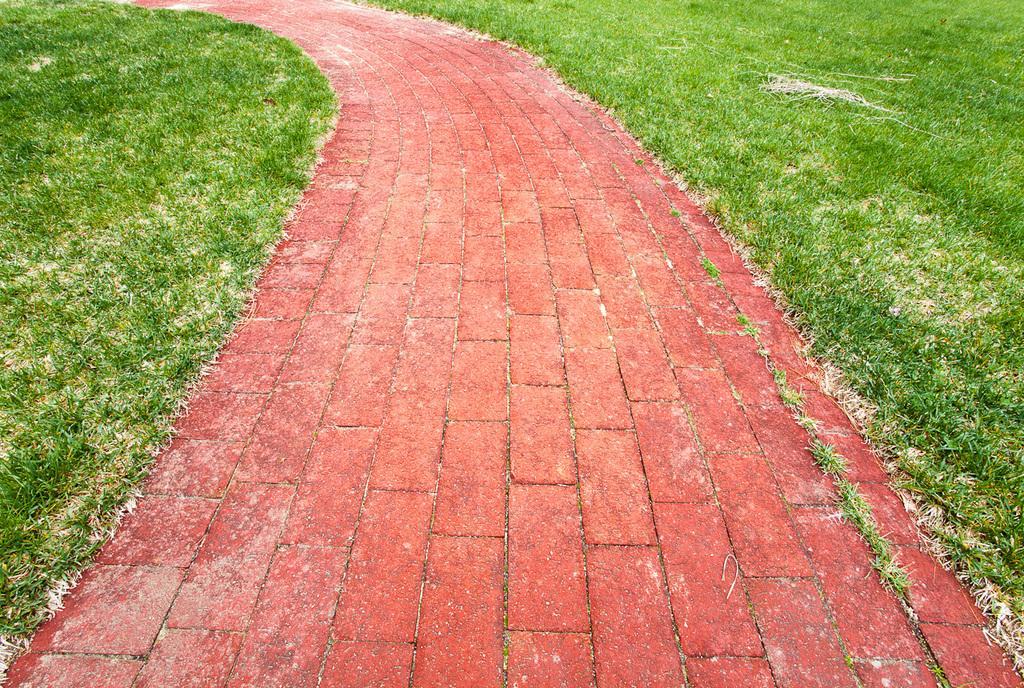How would you summarize this image in a sentence or two? In this picture we can see the grass and a path. 